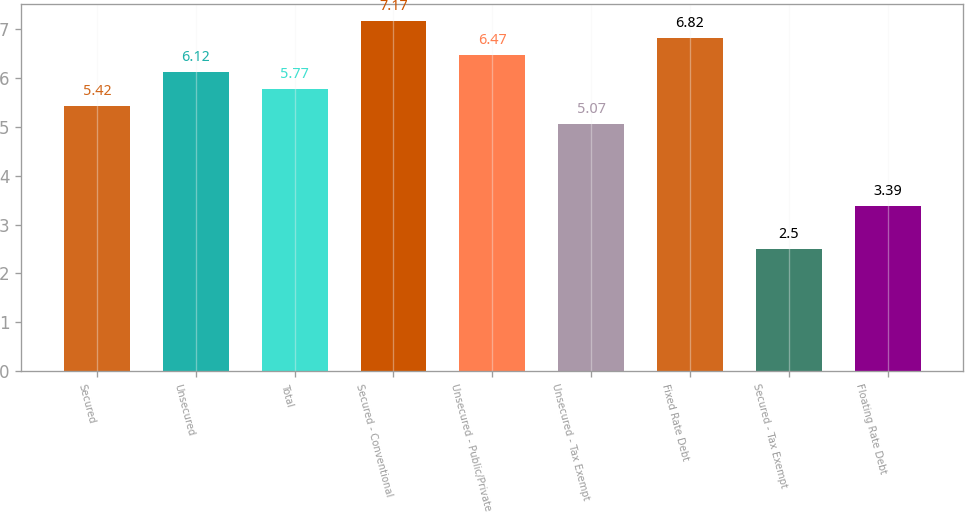Convert chart. <chart><loc_0><loc_0><loc_500><loc_500><bar_chart><fcel>Secured<fcel>Unsecured<fcel>Total<fcel>Secured - Conventional<fcel>Unsecured - Public/Private<fcel>Unsecured - Tax Exempt<fcel>Fixed Rate Debt<fcel>Secured - Tax Exempt<fcel>Floating Rate Debt<nl><fcel>5.42<fcel>6.12<fcel>5.77<fcel>7.17<fcel>6.47<fcel>5.07<fcel>6.82<fcel>2.5<fcel>3.39<nl></chart> 